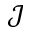Convert formula to latex. <formula><loc_0><loc_0><loc_500><loc_500>\mathcal { J }</formula> 